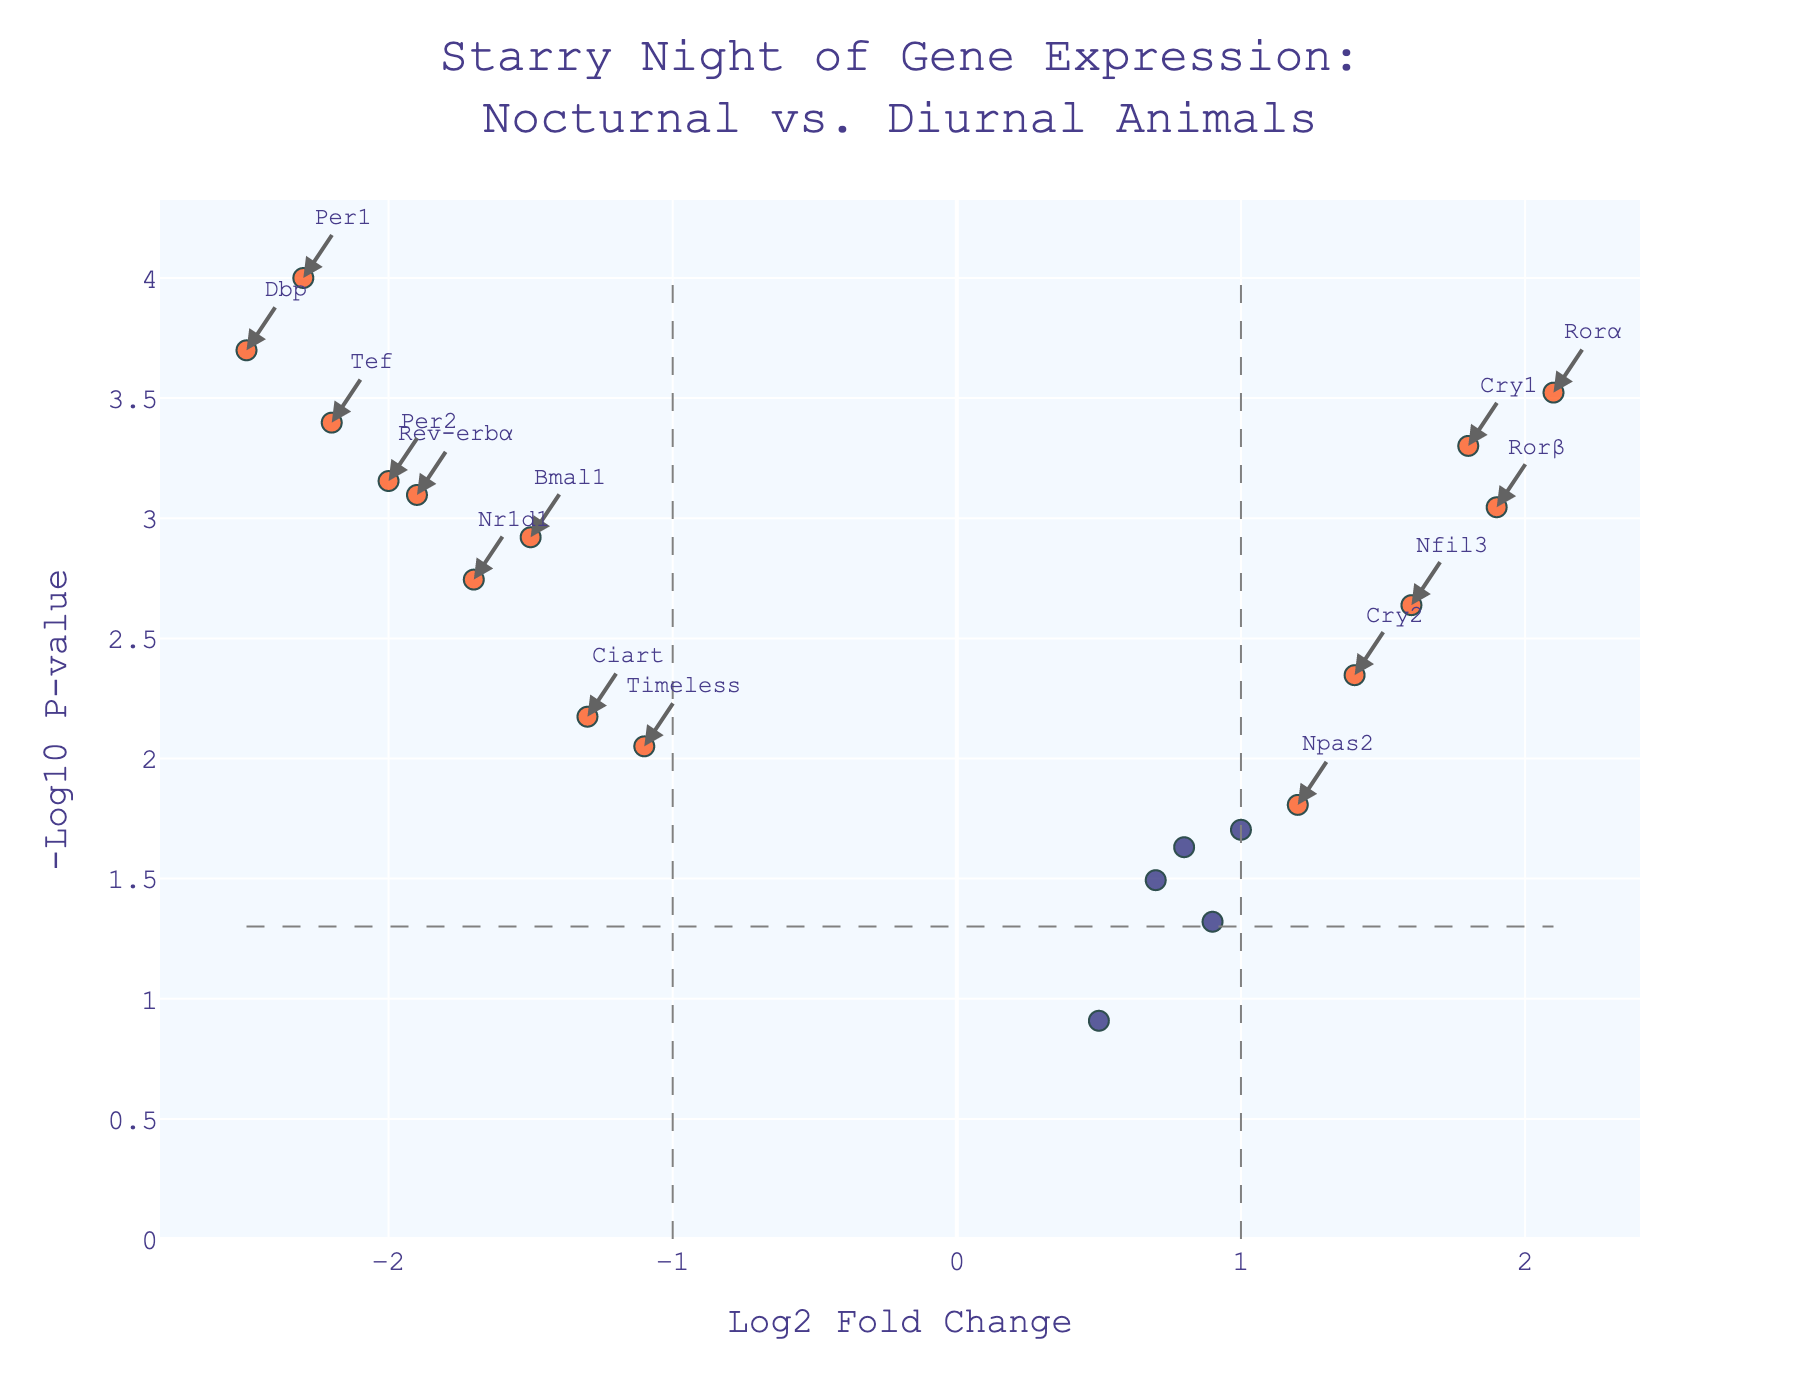What is the title of the plot? The title is typically located at the top of the figure and is used to describe what the plot represents. In this case, the title is provided as 'Starry Night of Gene Expression:<br>Nocturnal vs. Diurnal Animals.'
Answer: Starry Night of Gene Expression: Nocturnal vs. Diurnal Animals What does the x-axis represent? The x-axis in this plot is labeled 'Log2 Fold Change,' which indicates the ratio of gene expression levels between nocturnal and diurnal animals on a logarithmic scale.
Answer: Log2 Fold Change What does the y-axis represent? The y-axis in this plot is labeled '-Log10 P-value,' meaning it displays the negative logarithm (base 10) of the p-value, which indicates the statistical significance of the observed differences.
Answer: -Log10 P-value How are significant genes visually distinguished in the plot? Significant genes are differentiated by color. Non-significant genes are colored in a darker shade, while significant genes are highlighted using a more vivid color. Additionally, significant genes may have annotations pointing to their respective data points.
Answer: By color and annotations Which gene shows the highest log2 fold change in favor of nocturnal animals? To find the gene with the highest log2 fold change in favor of nocturnal animals, look for the data point farthest to the left with a significant color. This corresponds to the gene with the lowest log2 fold change. The gene Dbp has the highest negative log2 fold change.
Answer: Dbp Which gene has the smallest p-value? The gene with the smallest p-value will correspond to the point with the highest y-value (largest -log10(p-value)). By observing the plot, the gene Per1 is at the highest position on the y-axis.
Answer: Per1 How many genes are classified as significant based on the plot? Significant genes are highlighted differently and usually have annotations. By counting the annotated genes, you can determine the number of significant genes. There are 15 significant genes in the plot.
Answer: 15 What is the log2 fold change value for the gene 'Clock'? Locate the data point annotated with 'Clock.' The x-coordinate of this point represents the log2 fold change value. The 'Clock' gene has a log2 fold change value of 0.7.
Answer: 0.7 Which genes have a significant log2 fold change less than -1? Look for genes that are both significant and have an x-coordinate (log2 fold change) less than -1. These genes include Per1, Bmal1, Dbp, Per2, Nr1d1, Tef, and Timeless.
Answer: Per1, Bmal1, Dbp, Per2, Nr1d1, Tef, Timeless Are any genes significant with a log2 fold change between -0.5 and 0.5? Scan the plot for significant genes within the range of x-coordinates from -0.5 to 0.5. There appear to be no significant genes in this range given the annotations in the plot.
Answer: No 